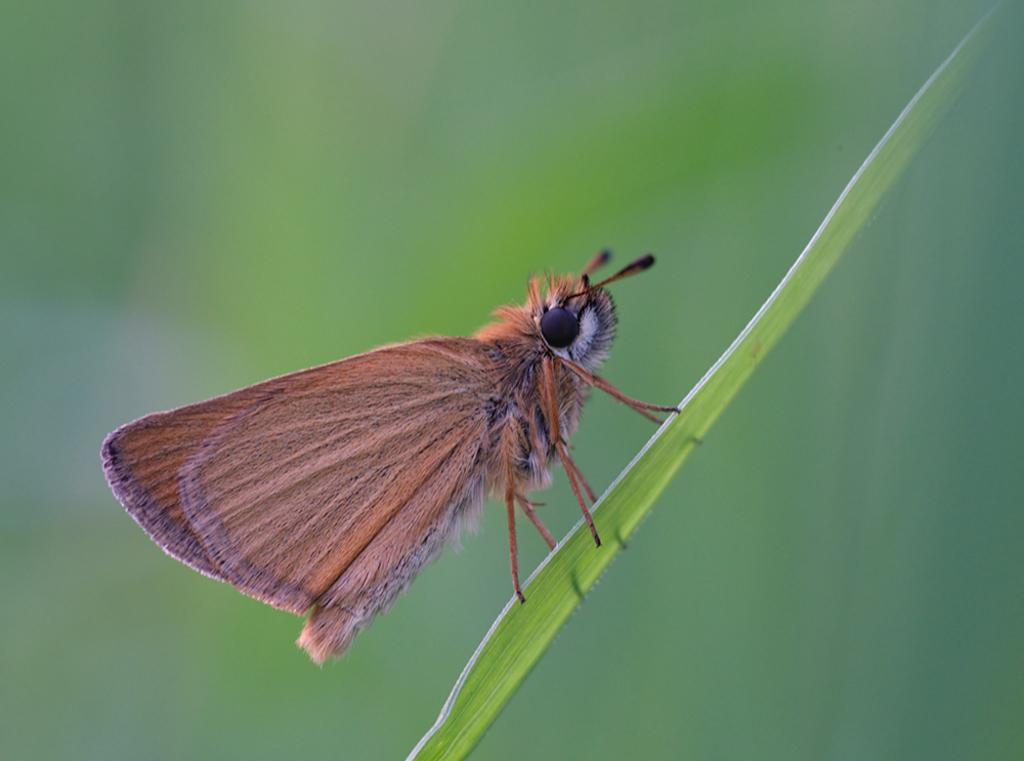What is the main subject of the image? There is a butterfly in the image. Where is the butterfly located in the image? The butterfly is standing on a leaf. Can you see a mountain in the background of the image? There is no mountain visible in the image; it only features a butterfly standing on a leaf. 